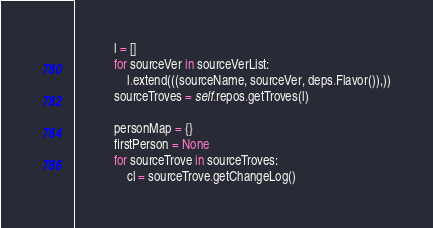Convert code to text. <code><loc_0><loc_0><loc_500><loc_500><_Python_>            l = []
            for sourceVer in sourceVerList:
                l.extend(((sourceName, sourceVer, deps.Flavor()),))
            sourceTroves = self.repos.getTroves(l)

            personMap = {}
            firstPerson = None
            for sourceTrove in sourceTroves:
                cl = sourceTrove.getChangeLog()</code> 